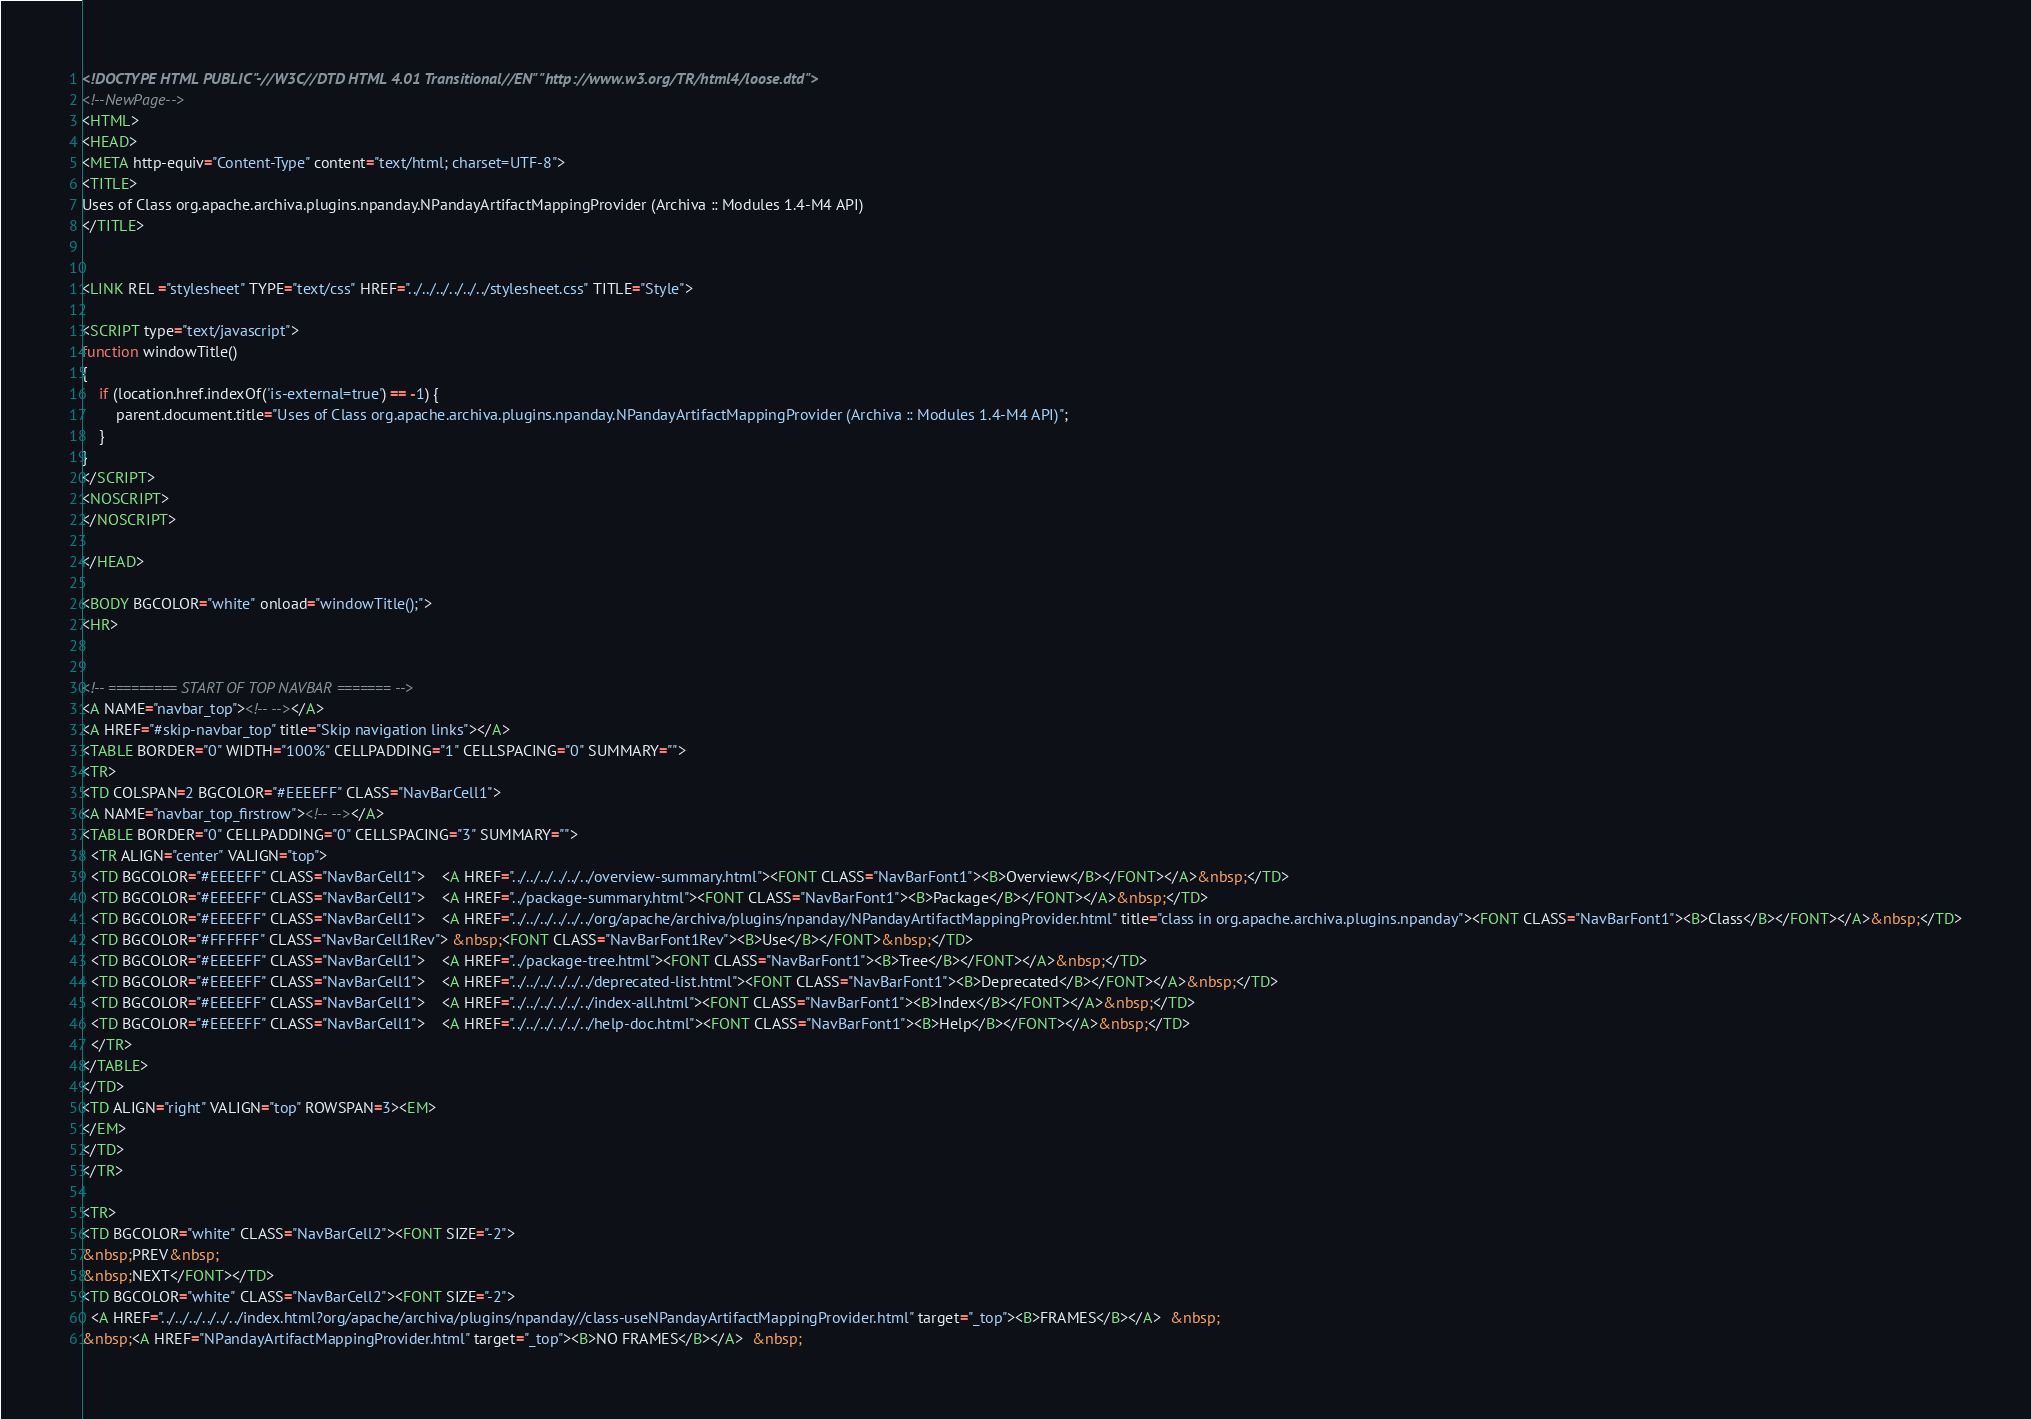<code> <loc_0><loc_0><loc_500><loc_500><_HTML_><!DOCTYPE HTML PUBLIC "-//W3C//DTD HTML 4.01 Transitional//EN" "http://www.w3.org/TR/html4/loose.dtd">
<!--NewPage-->
<HTML>
<HEAD>
<META http-equiv="Content-Type" content="text/html; charset=UTF-8">
<TITLE>
Uses of Class org.apache.archiva.plugins.npanday.NPandayArtifactMappingProvider (Archiva :: Modules 1.4-M4 API)
</TITLE>


<LINK REL ="stylesheet" TYPE="text/css" HREF="../../../../../../stylesheet.css" TITLE="Style">

<SCRIPT type="text/javascript">
function windowTitle()
{
    if (location.href.indexOf('is-external=true') == -1) {
        parent.document.title="Uses of Class org.apache.archiva.plugins.npanday.NPandayArtifactMappingProvider (Archiva :: Modules 1.4-M4 API)";
    }
}
</SCRIPT>
<NOSCRIPT>
</NOSCRIPT>

</HEAD>

<BODY BGCOLOR="white" onload="windowTitle();">
<HR>


<!-- ========= START OF TOP NAVBAR ======= -->
<A NAME="navbar_top"><!-- --></A>
<A HREF="#skip-navbar_top" title="Skip navigation links"></A>
<TABLE BORDER="0" WIDTH="100%" CELLPADDING="1" CELLSPACING="0" SUMMARY="">
<TR>
<TD COLSPAN=2 BGCOLOR="#EEEEFF" CLASS="NavBarCell1">
<A NAME="navbar_top_firstrow"><!-- --></A>
<TABLE BORDER="0" CELLPADDING="0" CELLSPACING="3" SUMMARY="">
  <TR ALIGN="center" VALIGN="top">
  <TD BGCOLOR="#EEEEFF" CLASS="NavBarCell1">    <A HREF="../../../../../../overview-summary.html"><FONT CLASS="NavBarFont1"><B>Overview</B></FONT></A>&nbsp;</TD>
  <TD BGCOLOR="#EEEEFF" CLASS="NavBarCell1">    <A HREF="../package-summary.html"><FONT CLASS="NavBarFont1"><B>Package</B></FONT></A>&nbsp;</TD>
  <TD BGCOLOR="#EEEEFF" CLASS="NavBarCell1">    <A HREF="../../../../../../org/apache/archiva/plugins/npanday/NPandayArtifactMappingProvider.html" title="class in org.apache.archiva.plugins.npanday"><FONT CLASS="NavBarFont1"><B>Class</B></FONT></A>&nbsp;</TD>
  <TD BGCOLOR="#FFFFFF" CLASS="NavBarCell1Rev"> &nbsp;<FONT CLASS="NavBarFont1Rev"><B>Use</B></FONT>&nbsp;</TD>
  <TD BGCOLOR="#EEEEFF" CLASS="NavBarCell1">    <A HREF="../package-tree.html"><FONT CLASS="NavBarFont1"><B>Tree</B></FONT></A>&nbsp;</TD>
  <TD BGCOLOR="#EEEEFF" CLASS="NavBarCell1">    <A HREF="../../../../../../deprecated-list.html"><FONT CLASS="NavBarFont1"><B>Deprecated</B></FONT></A>&nbsp;</TD>
  <TD BGCOLOR="#EEEEFF" CLASS="NavBarCell1">    <A HREF="../../../../../../index-all.html"><FONT CLASS="NavBarFont1"><B>Index</B></FONT></A>&nbsp;</TD>
  <TD BGCOLOR="#EEEEFF" CLASS="NavBarCell1">    <A HREF="../../../../../../help-doc.html"><FONT CLASS="NavBarFont1"><B>Help</B></FONT></A>&nbsp;</TD>
  </TR>
</TABLE>
</TD>
<TD ALIGN="right" VALIGN="top" ROWSPAN=3><EM>
</EM>
</TD>
</TR>

<TR>
<TD BGCOLOR="white" CLASS="NavBarCell2"><FONT SIZE="-2">
&nbsp;PREV&nbsp;
&nbsp;NEXT</FONT></TD>
<TD BGCOLOR="white" CLASS="NavBarCell2"><FONT SIZE="-2">
  <A HREF="../../../../../../index.html?org/apache/archiva/plugins/npanday//class-useNPandayArtifactMappingProvider.html" target="_top"><B>FRAMES</B></A>  &nbsp;
&nbsp;<A HREF="NPandayArtifactMappingProvider.html" target="_top"><B>NO FRAMES</B></A>  &nbsp;</code> 